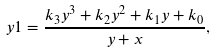<formula> <loc_0><loc_0><loc_500><loc_500>\ y 1 = { \frac { k _ { 3 } { y } ^ { 3 } + k _ { 2 } { y } ^ { 2 } + k _ { 1 } y + k _ { 0 } } { y + x } } ,</formula> 